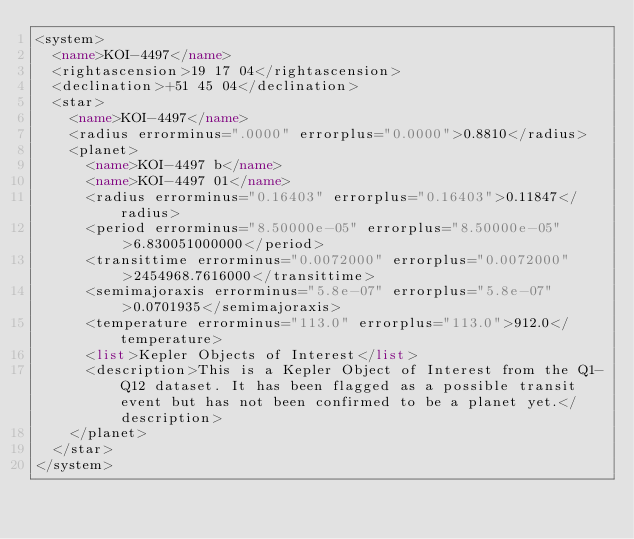Convert code to text. <code><loc_0><loc_0><loc_500><loc_500><_XML_><system>
	<name>KOI-4497</name>
	<rightascension>19 17 04</rightascension>
	<declination>+51 45 04</declination>
	<star>
		<name>KOI-4497</name>
		<radius errorminus=".0000" errorplus="0.0000">0.8810</radius>
		<planet>
			<name>KOI-4497 b</name>
			<name>KOI-4497 01</name>
			<radius errorminus="0.16403" errorplus="0.16403">0.11847</radius>
			<period errorminus="8.50000e-05" errorplus="8.50000e-05">6.830051000000</period>
			<transittime errorminus="0.0072000" errorplus="0.0072000">2454968.7616000</transittime>
			<semimajoraxis errorminus="5.8e-07" errorplus="5.8e-07">0.0701935</semimajoraxis>
			<temperature errorminus="113.0" errorplus="113.0">912.0</temperature>
			<list>Kepler Objects of Interest</list>
			<description>This is a Kepler Object of Interest from the Q1-Q12 dataset. It has been flagged as a possible transit event but has not been confirmed to be a planet yet.</description>
		</planet>
	</star>
</system>
</code> 